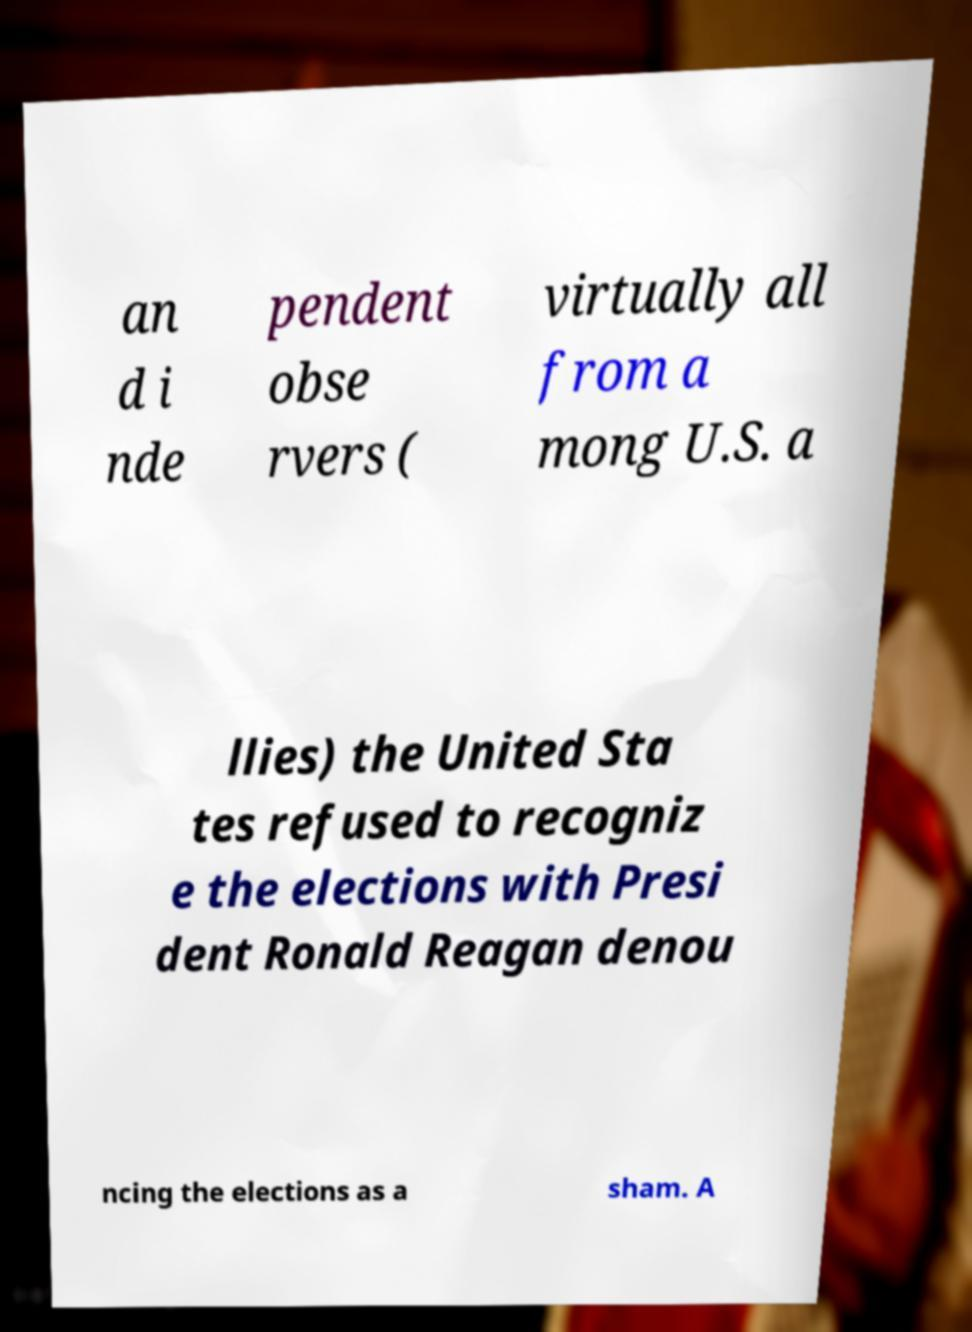For documentation purposes, I need the text within this image transcribed. Could you provide that? an d i nde pendent obse rvers ( virtually all from a mong U.S. a llies) the United Sta tes refused to recogniz e the elections with Presi dent Ronald Reagan denou ncing the elections as a sham. A 